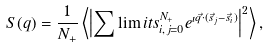<formula> <loc_0><loc_0><loc_500><loc_500>S ( q ) = \frac { 1 } { N _ { + } } \left < \left | \sum \lim i t s _ { i , j = 0 } ^ { N _ { + } } e ^ { \imath \vec { q } \cdot ( \vec { s } _ { j } - \vec { s } _ { i } ) } \right | ^ { 2 } \right > ,</formula> 